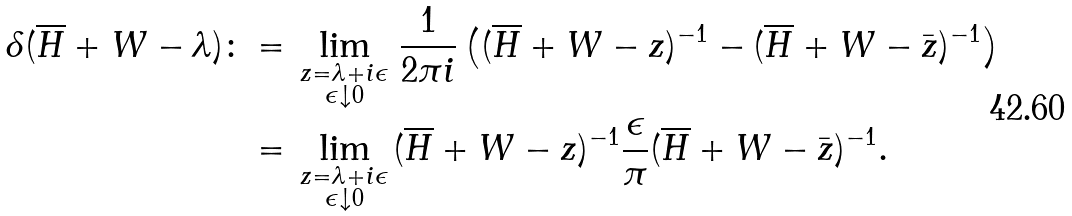<formula> <loc_0><loc_0><loc_500><loc_500>\delta ( \overline { H } + W - \lambda ) \colon & = \lim _ { \begin{smallmatrix} z = \lambda + i \epsilon \\ \epsilon \downarrow 0 \end{smallmatrix} } \frac { 1 } { 2 \pi i } \left ( ( \overline { H } + W - z ) ^ { - 1 } - ( \overline { H } + W - \bar { z } ) ^ { - 1 } \right ) \\ & = \lim _ { \begin{smallmatrix} z = \lambda + i \epsilon \\ \epsilon \downarrow 0 \end{smallmatrix} } ( \overline { H } + W - z ) ^ { - 1 } \frac { \epsilon } { \pi } ( \overline { H } + W - \bar { z } ) ^ { - 1 } .</formula> 